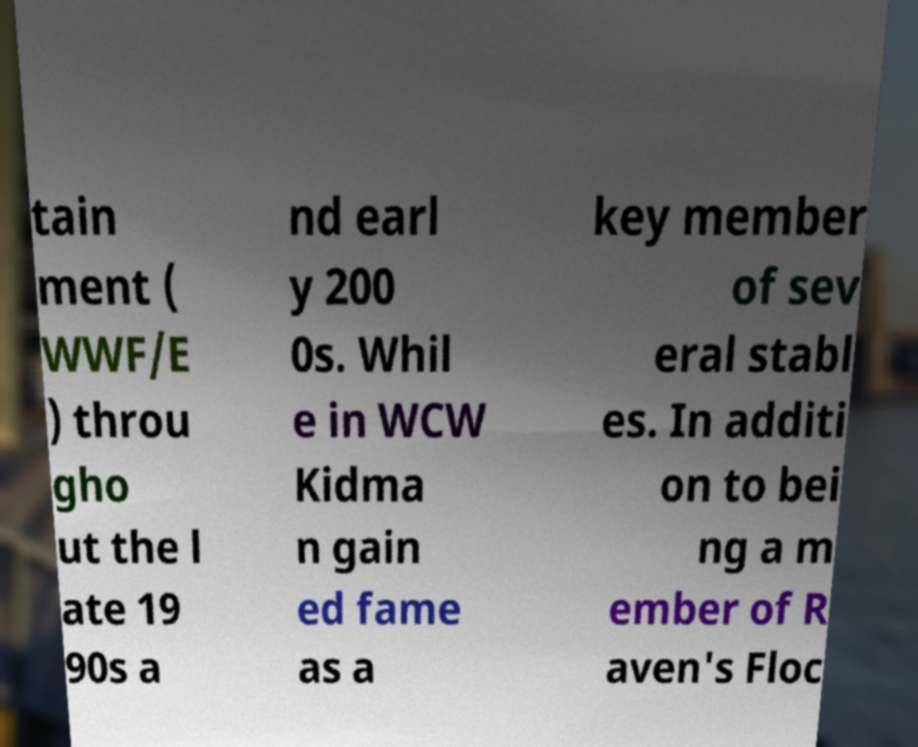Can you accurately transcribe the text from the provided image for me? tain ment ( WWF/E ) throu gho ut the l ate 19 90s a nd earl y 200 0s. Whil e in WCW Kidma n gain ed fame as a key member of sev eral stabl es. In additi on to bei ng a m ember of R aven's Floc 